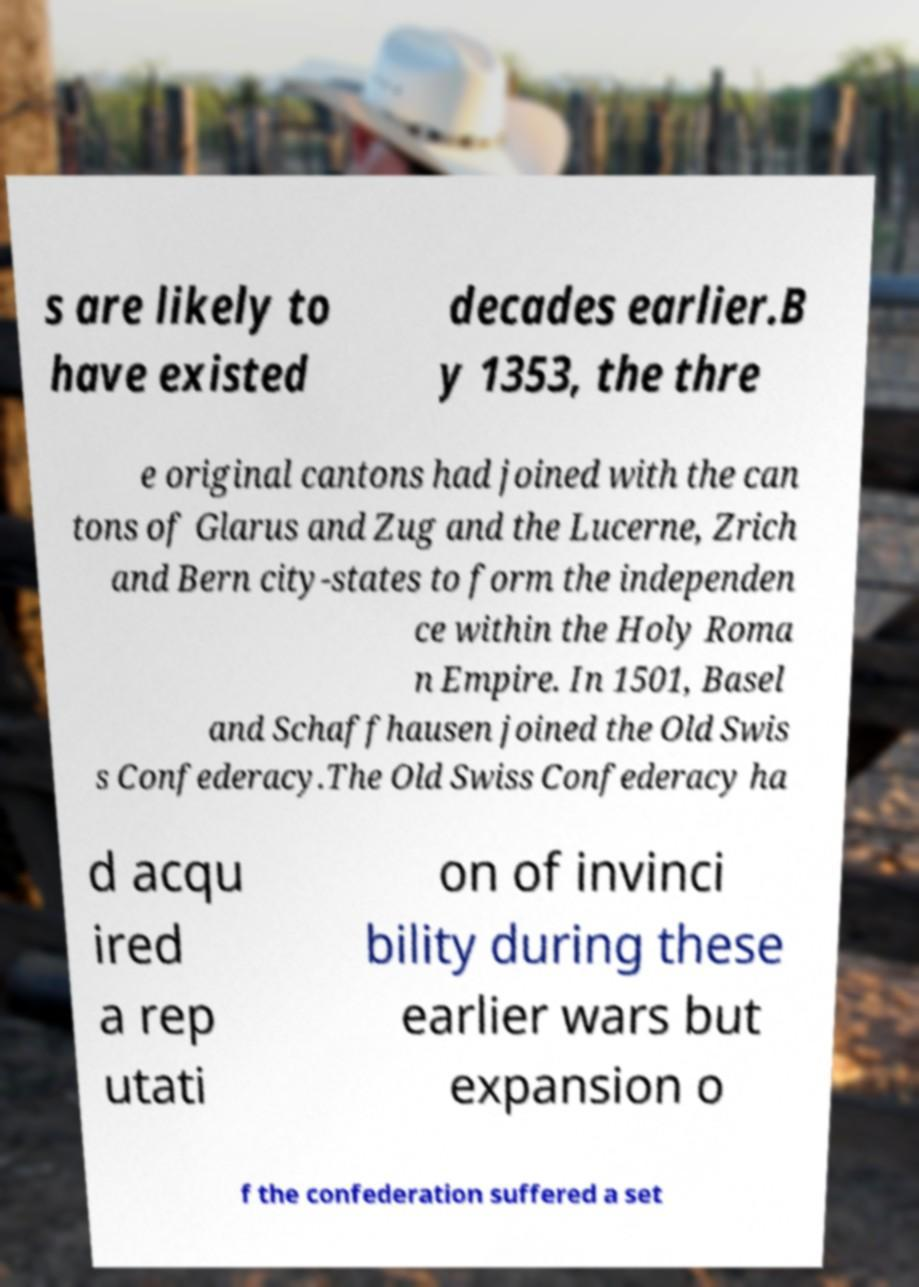Could you extract and type out the text from this image? s are likely to have existed decades earlier.B y 1353, the thre e original cantons had joined with the can tons of Glarus and Zug and the Lucerne, Zrich and Bern city-states to form the independen ce within the Holy Roma n Empire. In 1501, Basel and Schaffhausen joined the Old Swis s Confederacy.The Old Swiss Confederacy ha d acqu ired a rep utati on of invinci bility during these earlier wars but expansion o f the confederation suffered a set 